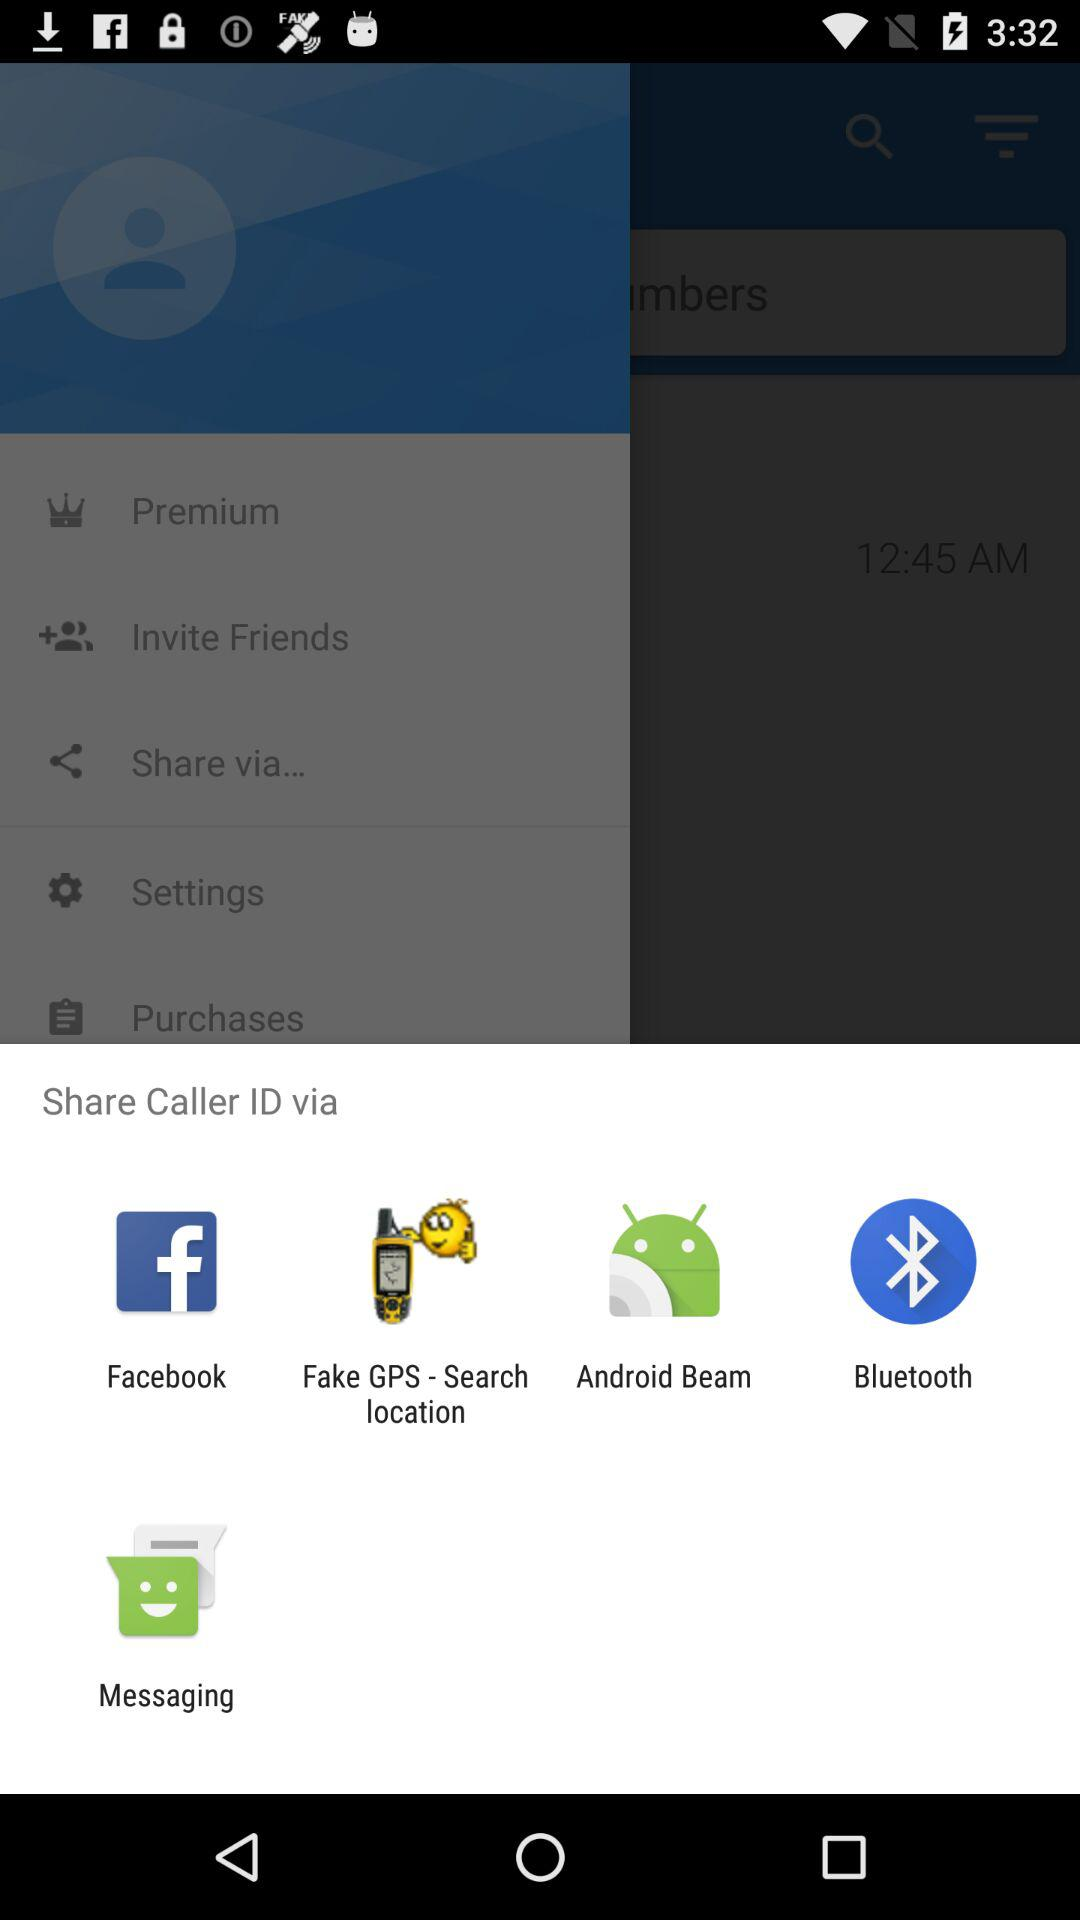What are the sharing options? The sharing options are "Facebook", "Fake GPS - Search location", "Android Beam", "Bluetooth" and "Messaging". 